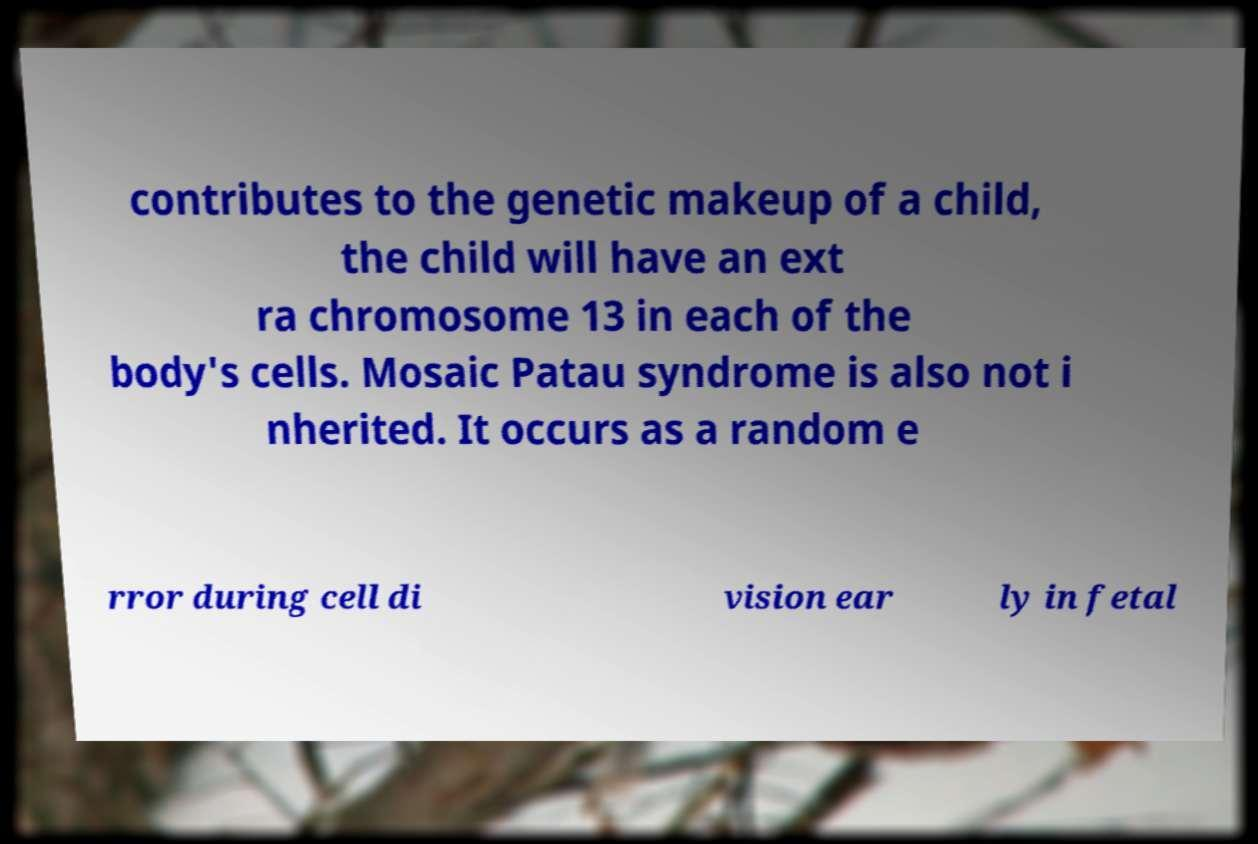Can you read and provide the text displayed in the image?This photo seems to have some interesting text. Can you extract and type it out for me? contributes to the genetic makeup of a child, the child will have an ext ra chromosome 13 in each of the body's cells. Mosaic Patau syndrome is also not i nherited. It occurs as a random e rror during cell di vision ear ly in fetal 